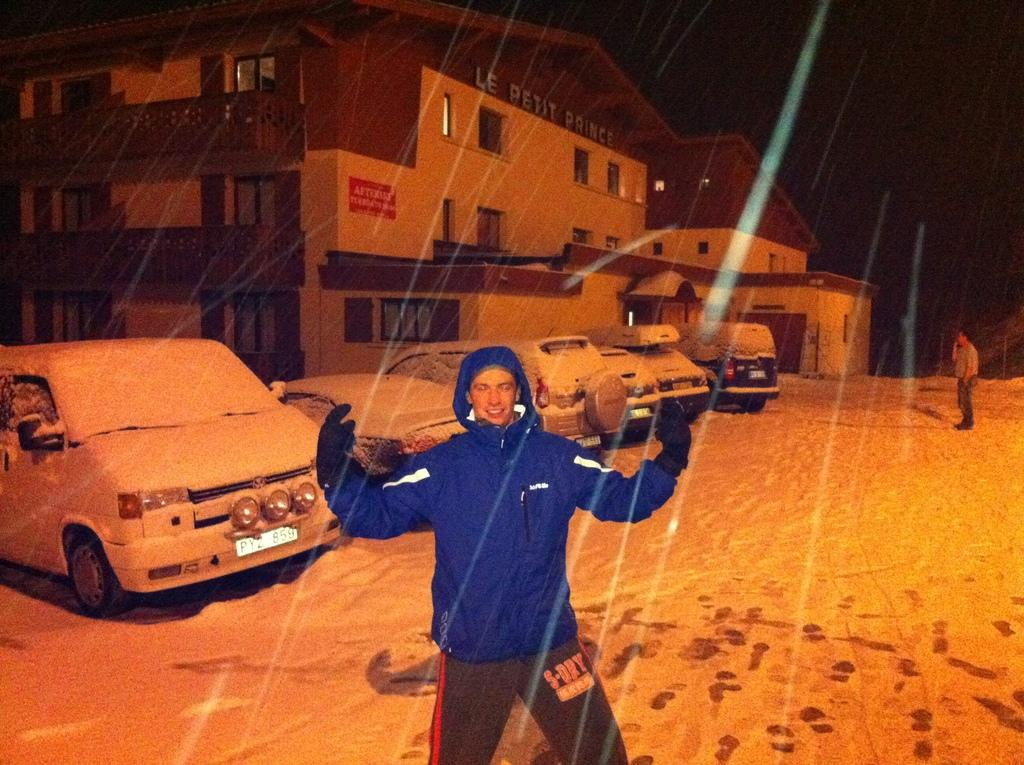How many people are present in the image? There are two men standing in the image. What can be seen in the background of the image? There is a building and vehicles in the background of the image. What is visible in the sky in the image? The sky is visible in the background of the image. What type of bells can be heard ringing in the image? There are no bells present in the image, and therefore no sound can be heard. 